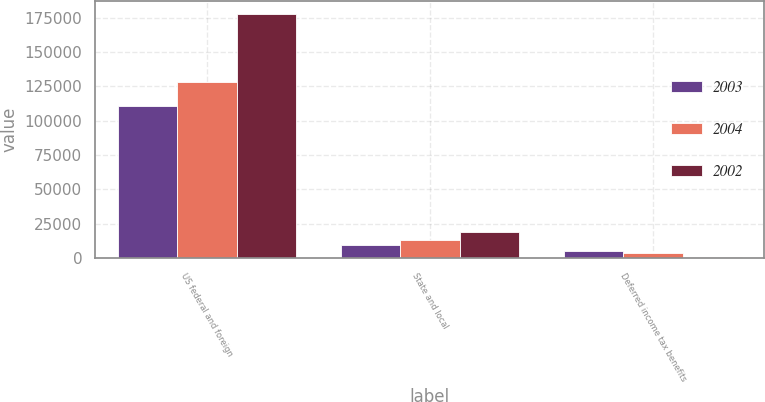Convert chart to OTSL. <chart><loc_0><loc_0><loc_500><loc_500><stacked_bar_chart><ecel><fcel>US federal and foreign<fcel>State and local<fcel>Deferred income tax benefits<nl><fcel>2003<fcel>111027<fcel>9429<fcel>5106<nl><fcel>2004<fcel>128380<fcel>13045<fcel>3396<nl><fcel>2002<fcel>177982<fcel>19099<fcel>558<nl></chart> 